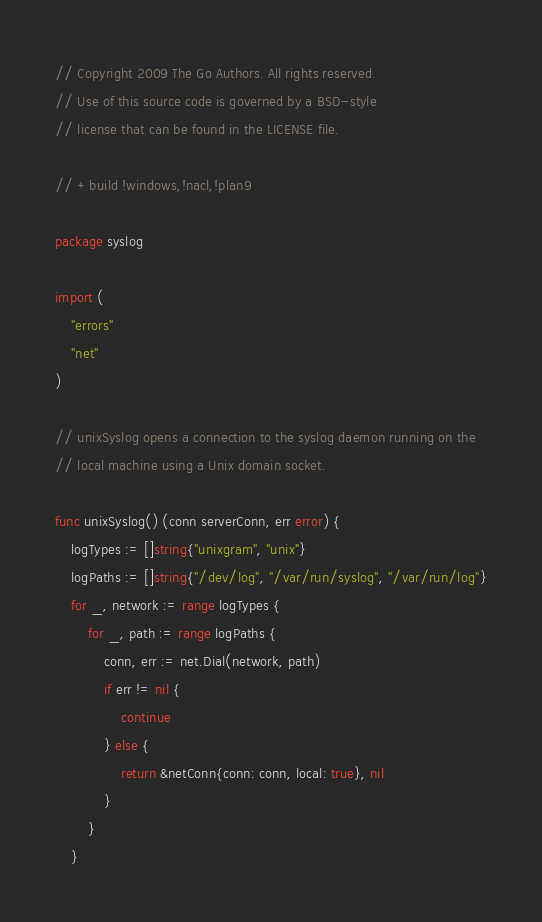<code> <loc_0><loc_0><loc_500><loc_500><_Go_>// Copyright 2009 The Go Authors. All rights reserved.
// Use of this source code is governed by a BSD-style
// license that can be found in the LICENSE file.

// +build !windows,!nacl,!plan9

package syslog

import (
	"errors"
	"net"
)

// unixSyslog opens a connection to the syslog daemon running on the
// local machine using a Unix domain socket.

func unixSyslog() (conn serverConn, err error) {
	logTypes := []string{"unixgram", "unix"}
	logPaths := []string{"/dev/log", "/var/run/syslog", "/var/run/log"}
	for _, network := range logTypes {
		for _, path := range logPaths {
			conn, err := net.Dial(network, path)
			if err != nil {
				continue
			} else {
				return &netConn{conn: conn, local: true}, nil
			}
		}
	}</code> 